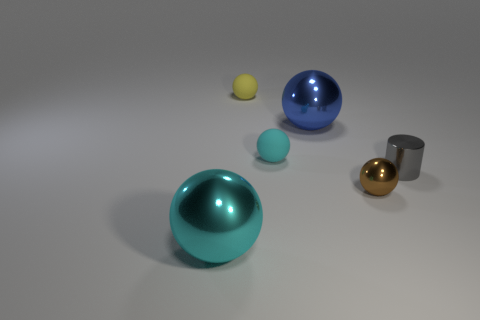There is a big metal object that is on the right side of the yellow thing; is it the same shape as the cyan rubber thing?
Keep it short and to the point. Yes. There is a cyan object to the right of the thing that is left of the small yellow ball; what shape is it?
Provide a short and direct response. Sphere. There is a metal thing that is behind the cyan object on the right side of the tiny thing behind the blue object; how big is it?
Offer a terse response. Large. What is the color of the other large thing that is the same shape as the large blue object?
Give a very brief answer. Cyan. Do the blue thing and the cyan metal object have the same size?
Your response must be concise. Yes. There is a gray thing that is in front of the yellow sphere; what material is it?
Your answer should be compact. Metal. What number of other things are there of the same shape as the big blue metallic object?
Make the answer very short. 4. Does the large cyan thing have the same shape as the brown shiny thing?
Offer a terse response. Yes. Are there any metallic spheres to the left of the blue metal thing?
Give a very brief answer. Yes. What number of objects are either blue shiny things or metal things?
Provide a succinct answer. 4. 